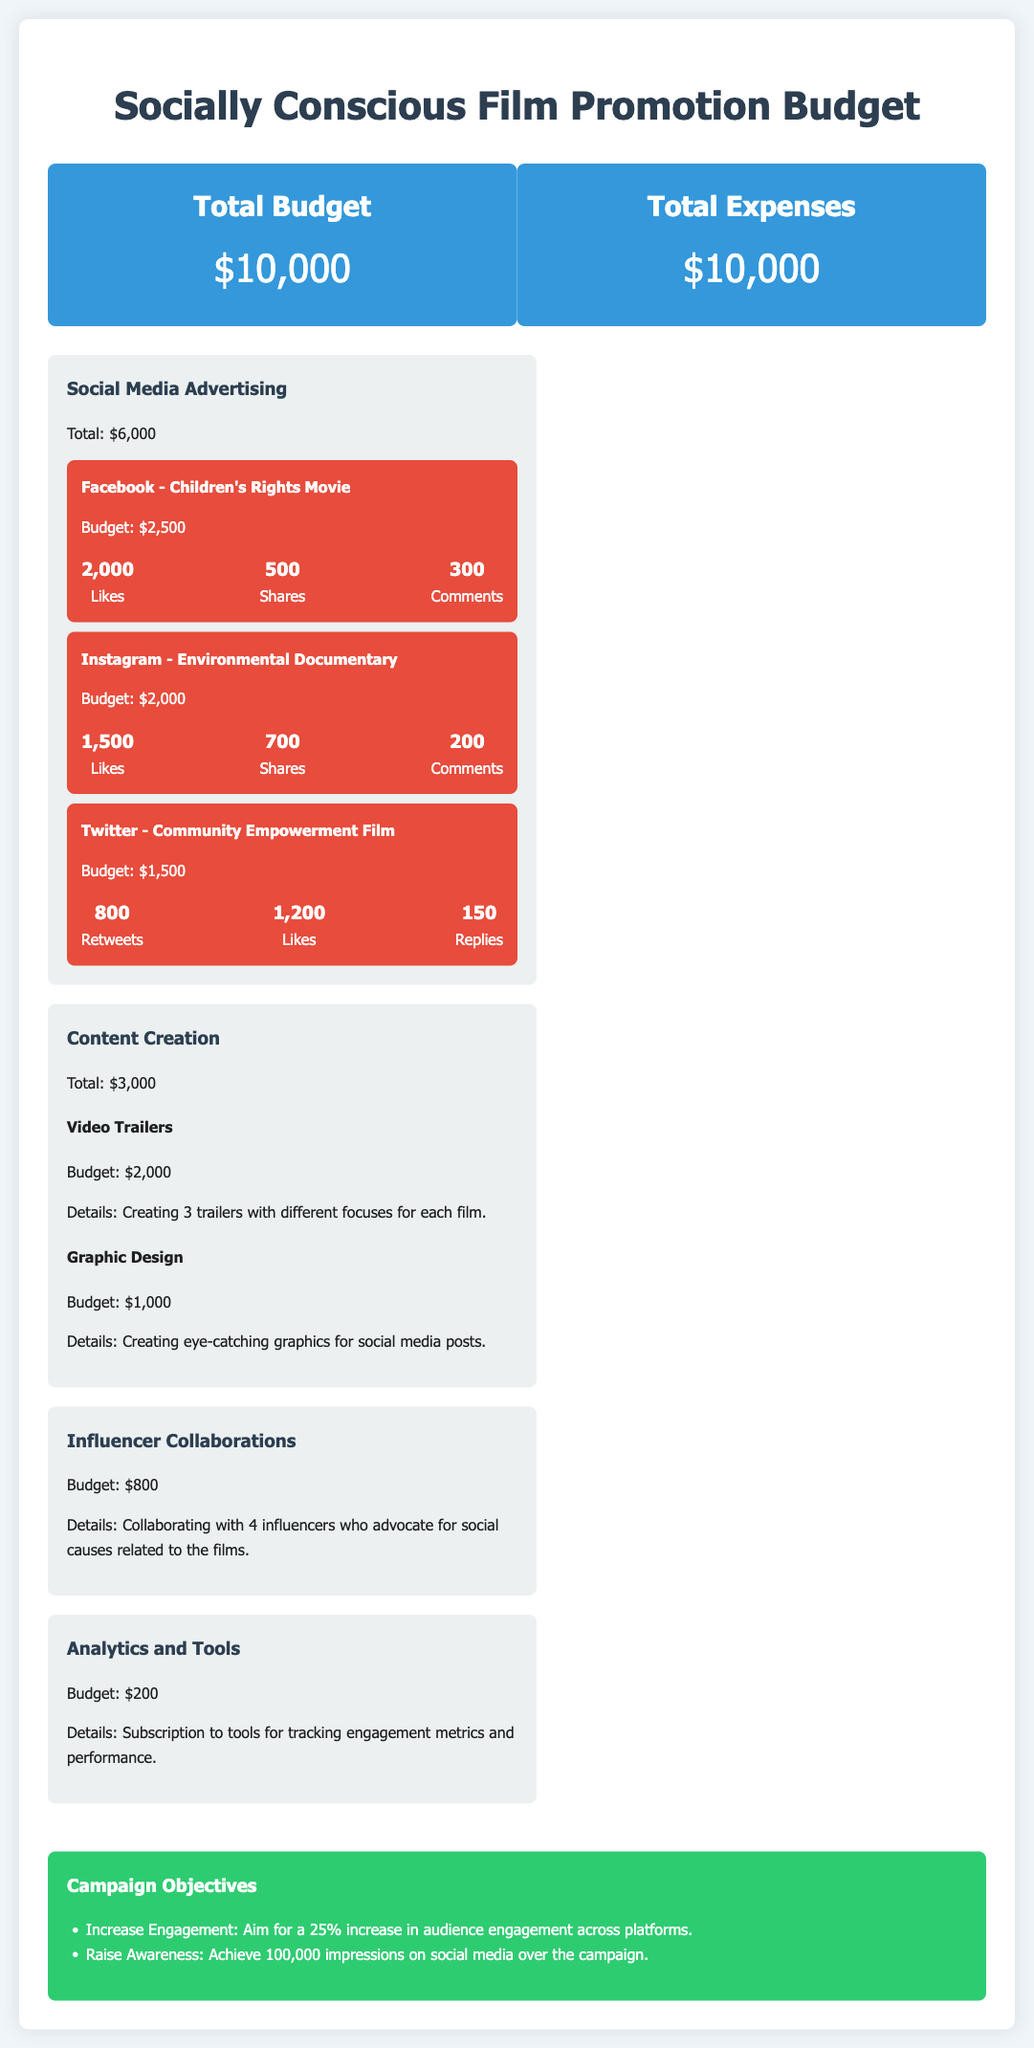What is the total budget for the promotion? The total budget is stated in the document as the overall financial allocation for the promotion of socially conscious films.
Answer: $10,000 How much is allocated for social media advertising? The document specifies the amount dedicated to social media advertising for promoting the films.
Answer: $6,000 What are the engagement metrics for Instagram? The document outlines specific engagement metrics associated with Instagram for the environmental documentary film.
Answer: 1,500 Likes, 700 Shares, 200 Comments What is the budget for content creation? Content creation is allocated a specific portion of the overall budget as mentioned in the document.
Answer: $3,000 How many influencers are involved in the collaborations? The document specifies the number of influencers participating in collaborations aimed at promoting the films.
Answer: 4 influencers What is the aim for increasing audience engagement? The document includes a goal related to enhancing audience interaction with the promotion.
Answer: 25% Which platform has the highest engagement in terms of likes? Information in the document compares the engagement metrics of different platforms, highlighting one that stands out for likes.
Answer: Facebook What is the budget for analytics and tools? The document states the financial allocation for subscriptions to tools that track engagement metrics.
Answer: $200 What is the total budget for influencer collaborations? The document provides a specific budget allocation for collaborations with influencers.
Answer: $800 